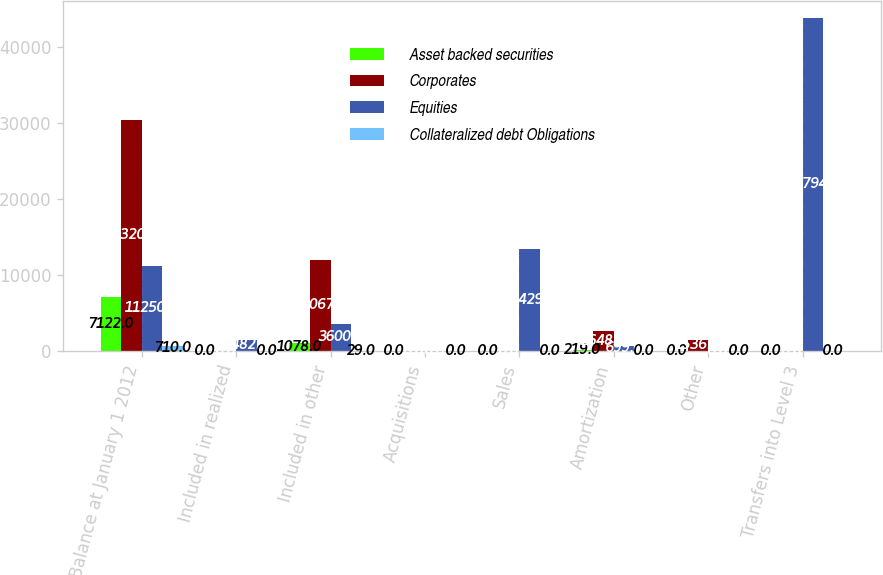<chart> <loc_0><loc_0><loc_500><loc_500><stacked_bar_chart><ecel><fcel>Balance at January 1 2012<fcel>Included in realized<fcel>Included in other<fcel>Acquisitions<fcel>Sales<fcel>Amortization<fcel>Other<fcel>Transfers into Level 3<nl><fcel>Asset backed securities<fcel>7122<fcel>0<fcel>1078<fcel>0<fcel>0<fcel>219<fcel>0<fcel>0<nl><fcel>Corporates<fcel>30320<fcel>0<fcel>12067<fcel>0<fcel>0<fcel>2648<fcel>1536<fcel>0<nl><fcel>Equities<fcel>11250<fcel>1482<fcel>3600<fcel>0<fcel>13429<fcel>699<fcel>0<fcel>43794<nl><fcel>Collateralized debt Obligations<fcel>710<fcel>0<fcel>29<fcel>0<fcel>0<fcel>0<fcel>0<fcel>0<nl></chart> 